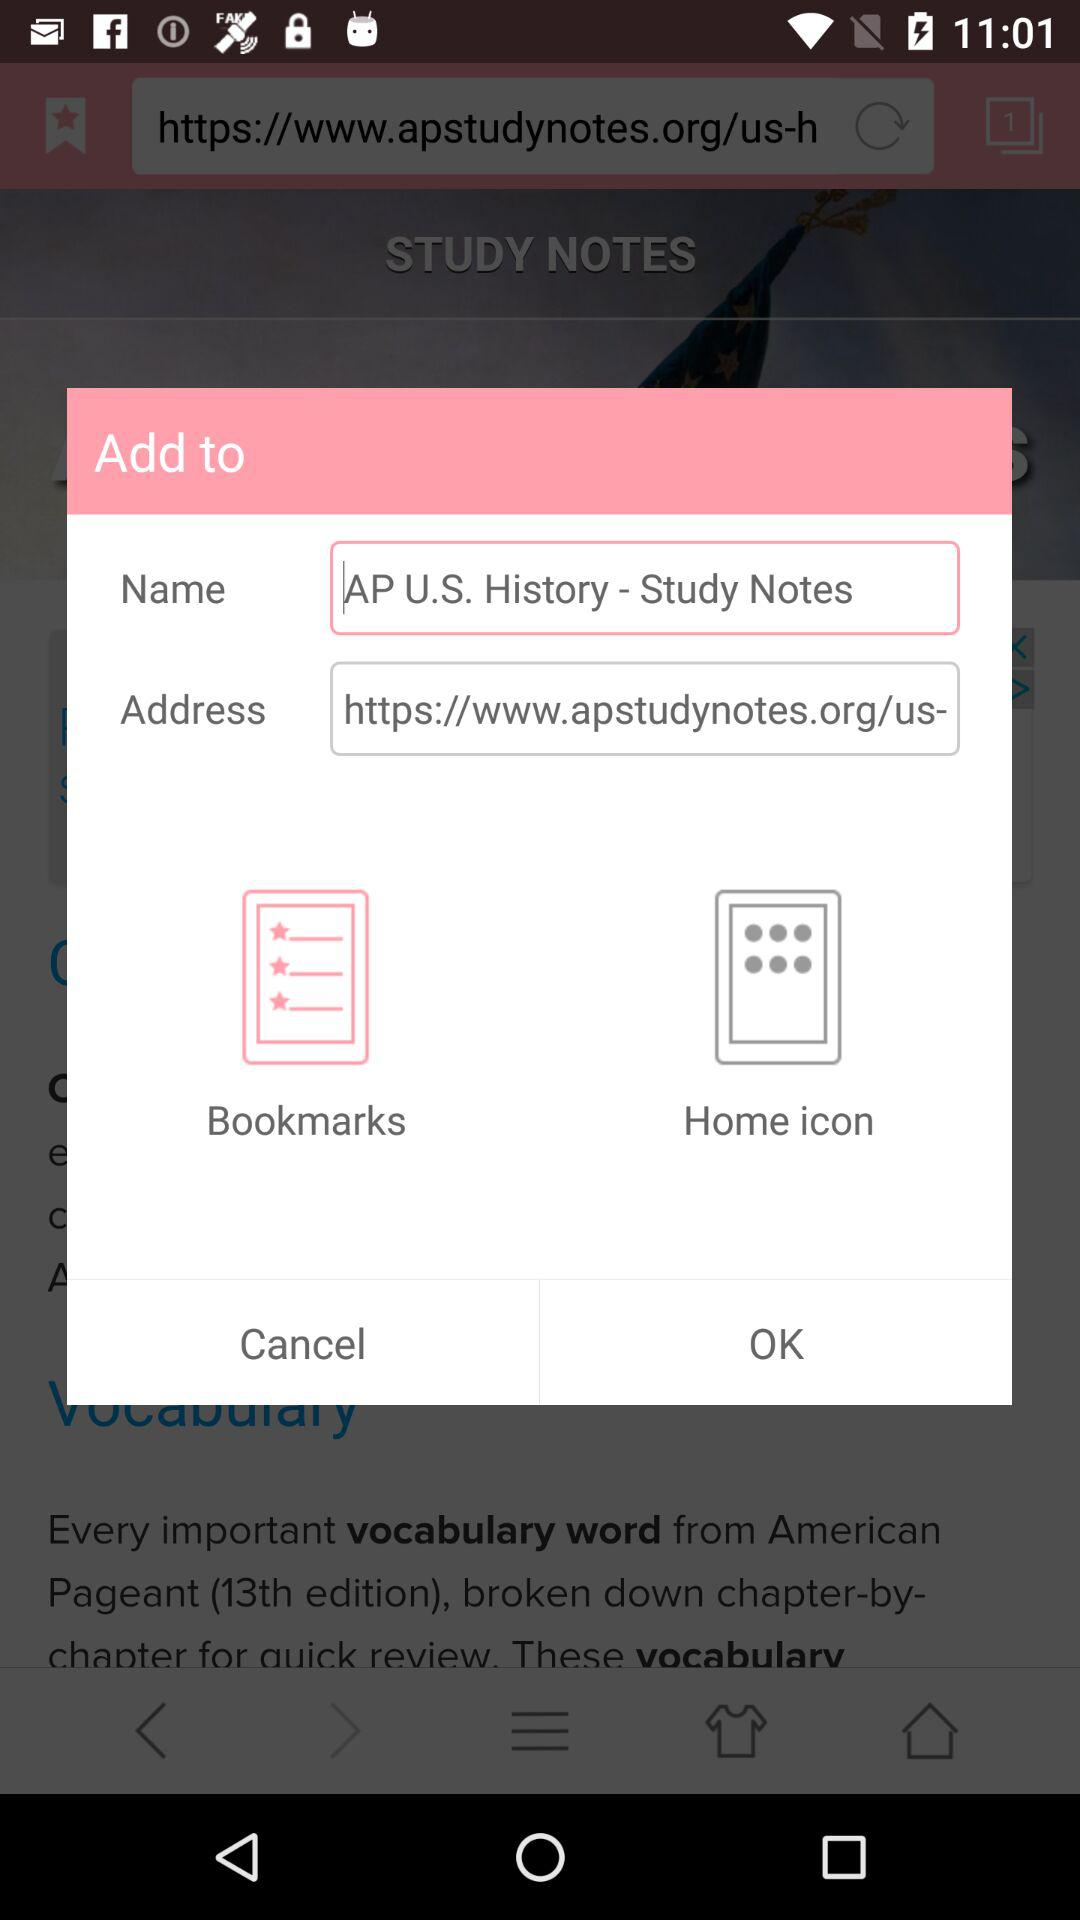What's the selected "Add to" option? The selected "Add to" option is "Bookmarks". 